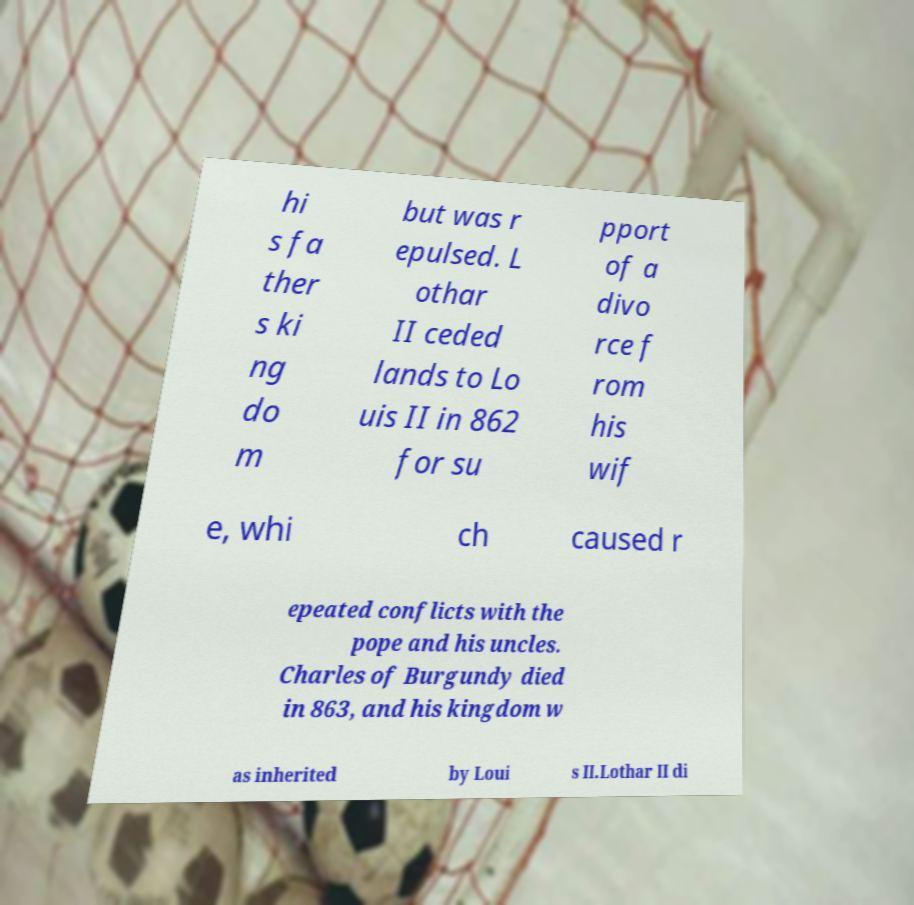Can you accurately transcribe the text from the provided image for me? hi s fa ther s ki ng do m but was r epulsed. L othar II ceded lands to Lo uis II in 862 for su pport of a divo rce f rom his wif e, whi ch caused r epeated conflicts with the pope and his uncles. Charles of Burgundy died in 863, and his kingdom w as inherited by Loui s II.Lothar II di 